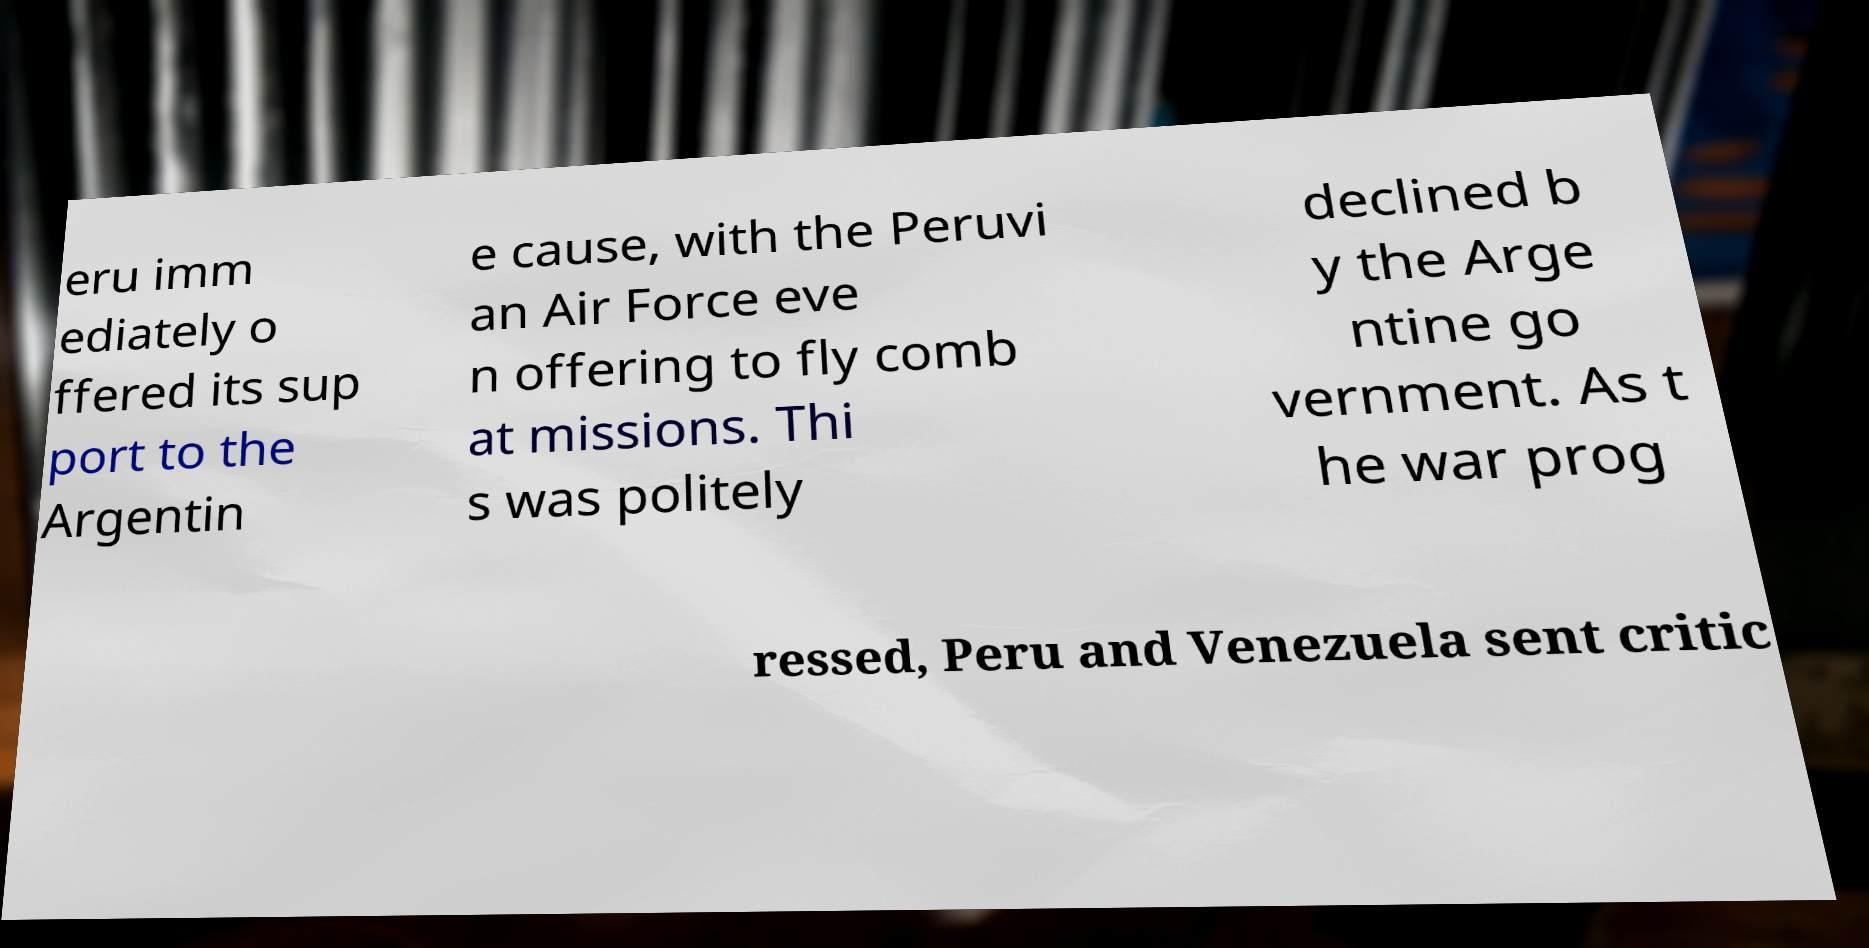Could you assist in decoding the text presented in this image and type it out clearly? eru imm ediately o ffered its sup port to the Argentin e cause, with the Peruvi an Air Force eve n offering to fly comb at missions. Thi s was politely declined b y the Arge ntine go vernment. As t he war prog ressed, Peru and Venezuela sent critic 